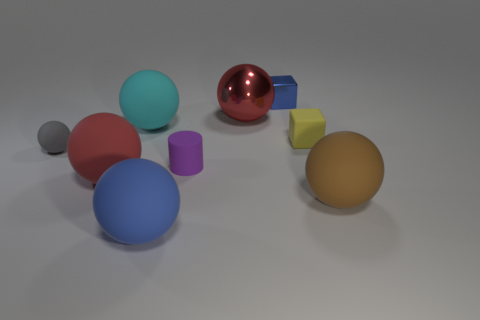Is the red object that is left of the cyan ball made of the same material as the yellow object?
Provide a succinct answer. Yes. Is the number of cylinders on the right side of the tiny rubber cylinder greater than the number of blue things behind the red rubber ball?
Give a very brief answer. No. What number of objects are tiny things that are in front of the red metallic object or blue rubber balls?
Your response must be concise. 4. The brown thing that is the same material as the gray ball is what shape?
Your answer should be compact. Sphere. Is there anything else that has the same shape as the purple object?
Keep it short and to the point. No. The ball that is both behind the purple rubber thing and in front of the yellow rubber cube is what color?
Provide a short and direct response. Gray. What number of balls are brown rubber objects or large cyan objects?
Ensure brevity in your answer.  2. What number of blue metallic blocks have the same size as the yellow cube?
Ensure brevity in your answer.  1. How many tiny gray rubber objects are on the right side of the big rubber thing that is on the right side of the big blue sphere?
Provide a succinct answer. 0. What size is the ball that is in front of the tiny gray matte ball and behind the large brown thing?
Offer a very short reply. Large. 